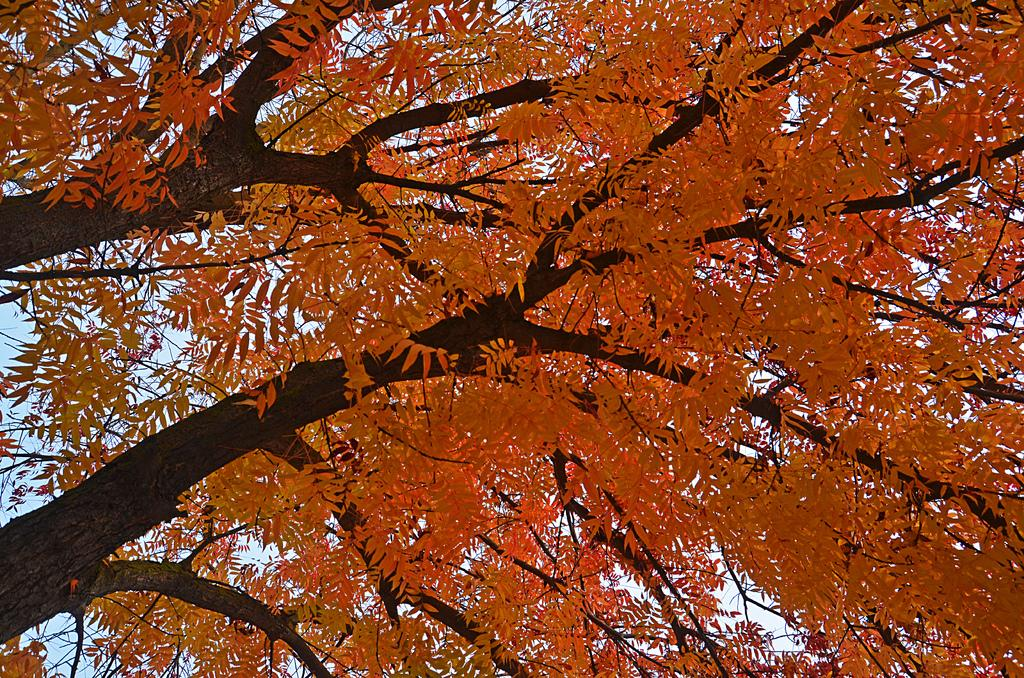How many trees are on the left side of the image? There are two trees on the left side of the image. What color are the leaves on the trees? The leaves on the trees are yellow. What can be seen in the background of the image? There is sky visible in the background of the image. How many sheep are visible in the image? There are no sheep present in the image. What temperature is the hot air balloon in the image? There is no hot air balloon present in the image. 